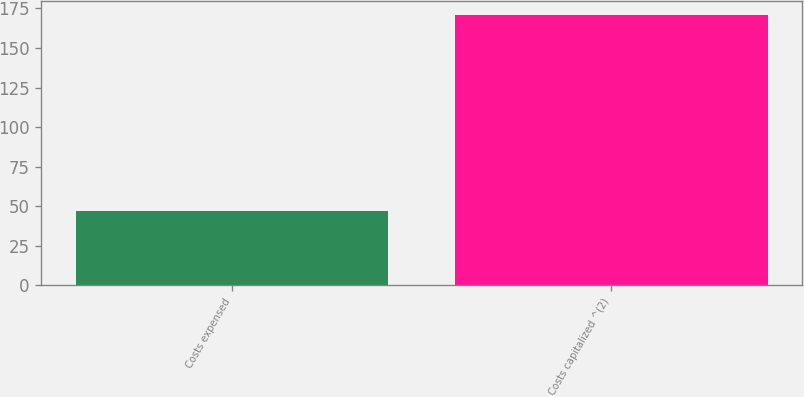Convert chart. <chart><loc_0><loc_0><loc_500><loc_500><bar_chart><fcel>Costs expensed<fcel>Costs capitalized ^(2)<nl><fcel>47<fcel>171<nl></chart> 